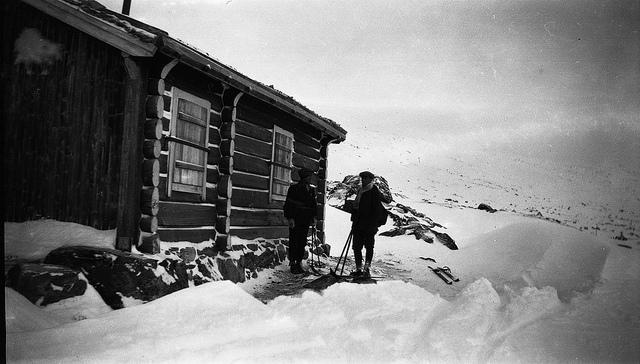What is the cabin made of?
Quick response, please. Wood. Is this a ski resort?
Answer briefly. Yes. What color is the snow?
Keep it brief. White. 